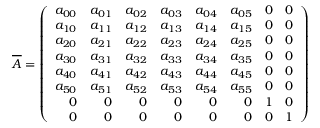<formula> <loc_0><loc_0><loc_500><loc_500>\overline { A } = \left ( \begin{array} { r r r r r r r r } { a _ { 0 0 } } & { a _ { 0 1 } } & { a _ { 0 2 } } & { a _ { 0 3 } } & { a _ { 0 4 } } & { a _ { 0 5 } } & { 0 } & { 0 } \\ { a _ { 1 0 } } & { a _ { 1 1 } } & { a _ { 1 2 } } & { a _ { 1 3 } } & { a _ { 1 4 } } & { a _ { 1 5 } } & { 0 } & { 0 } \\ { a _ { 2 0 } } & { a _ { 2 1 } } & { a _ { 2 2 } } & { a _ { 2 3 } } & { a _ { 2 4 } } & { a _ { 2 5 } } & { 0 } & { 0 } \\ { a _ { 3 0 } } & { a _ { 3 1 } } & { a _ { 3 2 } } & { a _ { 3 3 } } & { a _ { 3 4 } } & { a _ { 3 5 } } & { 0 } & { 0 } \\ { a _ { 4 0 } } & { a _ { 4 1 } } & { a _ { 4 2 } } & { a _ { 4 3 } } & { a _ { 4 4 } } & { a _ { 4 5 } } & { 0 } & { 0 } \\ { a _ { 5 0 } } & { a _ { 5 1 } } & { a _ { 5 2 } } & { a _ { 5 3 } } & { a _ { 5 4 } } & { a _ { 5 5 } } & { 0 } & { 0 } \\ { 0 } & { 0 } & { 0 } & { 0 } & { 0 } & { 0 } & { 1 } & { 0 } \\ { 0 } & { 0 } & { 0 } & { 0 } & { 0 } & { 0 } & { 0 } & { 1 } \end{array} \right )</formula> 